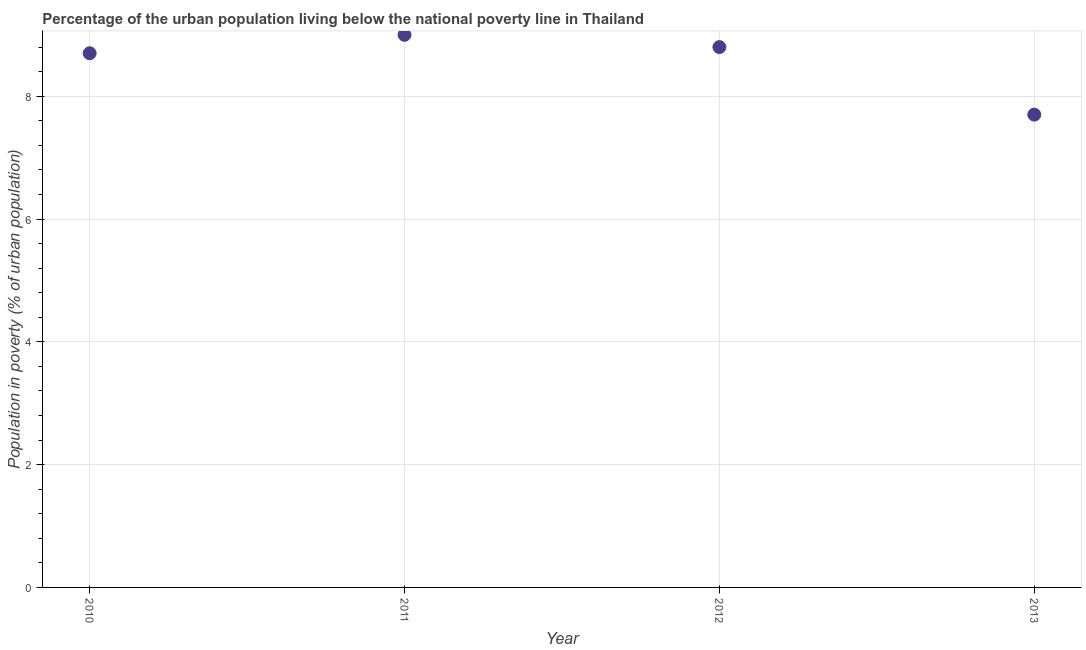In which year was the percentage of urban population living below poverty line maximum?
Make the answer very short. 2011. In which year was the percentage of urban population living below poverty line minimum?
Offer a terse response. 2013. What is the sum of the percentage of urban population living below poverty line?
Offer a very short reply. 34.2. What is the difference between the percentage of urban population living below poverty line in 2010 and 2011?
Keep it short and to the point. -0.3. What is the average percentage of urban population living below poverty line per year?
Your answer should be very brief. 8.55. What is the median percentage of urban population living below poverty line?
Keep it short and to the point. 8.75. In how many years, is the percentage of urban population living below poverty line greater than 8.4 %?
Provide a short and direct response. 3. What is the ratio of the percentage of urban population living below poverty line in 2011 to that in 2012?
Keep it short and to the point. 1.02. Is the percentage of urban population living below poverty line in 2012 less than that in 2013?
Your response must be concise. No. What is the difference between the highest and the second highest percentage of urban population living below poverty line?
Your response must be concise. 0.2. What is the difference between the highest and the lowest percentage of urban population living below poverty line?
Give a very brief answer. 1.3. In how many years, is the percentage of urban population living below poverty line greater than the average percentage of urban population living below poverty line taken over all years?
Provide a succinct answer. 3. Does the percentage of urban population living below poverty line monotonically increase over the years?
Make the answer very short. No. How many dotlines are there?
Your answer should be compact. 1. What is the difference between two consecutive major ticks on the Y-axis?
Provide a short and direct response. 2. Are the values on the major ticks of Y-axis written in scientific E-notation?
Your response must be concise. No. Does the graph contain any zero values?
Give a very brief answer. No. Does the graph contain grids?
Keep it short and to the point. Yes. What is the title of the graph?
Your answer should be very brief. Percentage of the urban population living below the national poverty line in Thailand. What is the label or title of the X-axis?
Give a very brief answer. Year. What is the label or title of the Y-axis?
Your response must be concise. Population in poverty (% of urban population). What is the Population in poverty (% of urban population) in 2010?
Ensure brevity in your answer.  8.7. What is the Population in poverty (% of urban population) in 2011?
Provide a succinct answer. 9. What is the difference between the Population in poverty (% of urban population) in 2010 and 2011?
Give a very brief answer. -0.3. What is the difference between the Population in poverty (% of urban population) in 2010 and 2012?
Ensure brevity in your answer.  -0.1. What is the ratio of the Population in poverty (% of urban population) in 2010 to that in 2011?
Your response must be concise. 0.97. What is the ratio of the Population in poverty (% of urban population) in 2010 to that in 2012?
Your answer should be very brief. 0.99. What is the ratio of the Population in poverty (% of urban population) in 2010 to that in 2013?
Offer a terse response. 1.13. What is the ratio of the Population in poverty (% of urban population) in 2011 to that in 2013?
Your answer should be very brief. 1.17. What is the ratio of the Population in poverty (% of urban population) in 2012 to that in 2013?
Your answer should be compact. 1.14. 